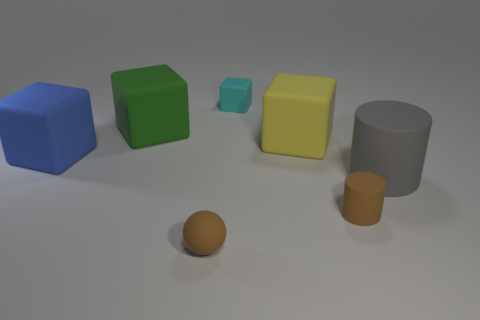Add 5 big blue rubber objects. How many big blue rubber objects exist? 6 Add 1 yellow blocks. How many objects exist? 8 Subtract all yellow blocks. How many blocks are left? 3 Subtract all small matte cubes. How many cubes are left? 3 Subtract 0 red cubes. How many objects are left? 7 Subtract all cubes. How many objects are left? 3 Subtract 1 balls. How many balls are left? 0 Subtract all yellow cubes. Subtract all gray cylinders. How many cubes are left? 3 Subtract all yellow cylinders. How many green blocks are left? 1 Subtract all purple metal cylinders. Subtract all tiny rubber cylinders. How many objects are left? 6 